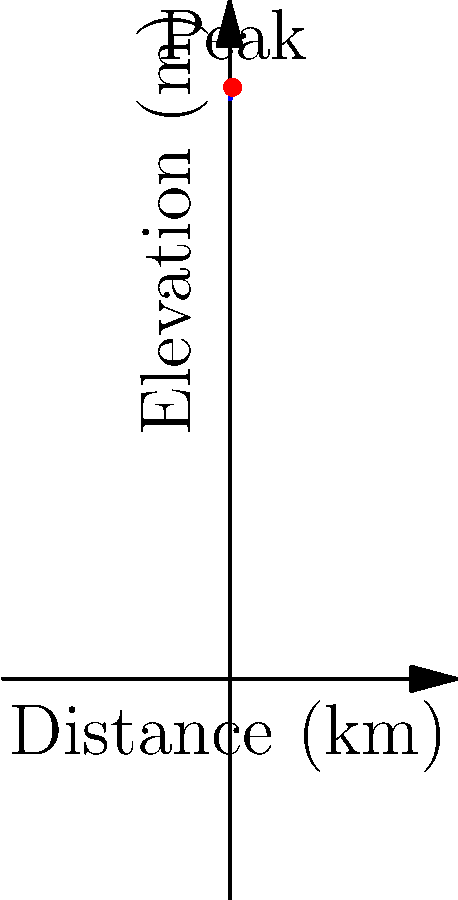As you plan your next spiritual journey through a mountain range, you model its elevation profile using the polynomial function $f(x) = 0.01x^4 - 0.4x^3 + 4x^2 - 8x + 1000$, where $x$ is the distance in kilometers from the starting point and $f(x)$ is the elevation in meters. At what distance from the starting point does the highest peak occur, and what is its elevation? To find the highest peak, we need to determine the maximum point of the function. This occurs where the derivative of the function is zero.

1. Find the derivative of $f(x)$:
   $f'(x) = 0.04x^3 - 1.2x^2 + 8x - 8$

2. Set $f'(x) = 0$ and solve for $x$:
   $0.04x^3 - 1.2x^2 + 8x - 8 = 0$

3. This cubic equation is difficult to solve by hand, but we can use a graphing calculator or computer algebra system to find that the only real solution in our domain is $x = 5$.

4. To confirm this is a maximum (not a minimum), we can check the second derivative:
   $f''(x) = 0.12x^2 - 2.4x + 8$
   $f''(5) = 0.12(25) - 2.4(5) + 8 = 3 - 12 + 8 = -1 < 0$
   Since $f''(5) < 0$, this confirms that $x = 5$ gives a maximum.

5. Calculate the elevation at $x = 5$:
   $f(5) = 0.01(5^4) - 0.4(5^3) + 4(5^2) - 8(5) + 1000$
   $= 6.25 - 50 + 100 - 40 + 1000 = 1016.25$

Therefore, the highest peak occurs 5 km from the starting point and has an elevation of 1016.25 meters.
Answer: 5 km from start, 1016.25 m elevation 